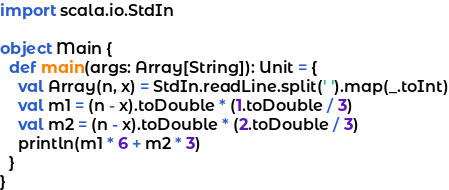<code> <loc_0><loc_0><loc_500><loc_500><_Scala_>import scala.io.StdIn

object Main {
  def main(args: Array[String]): Unit = {
    val Array(n, x) = StdIn.readLine.split(' ').map(_.toInt)
    val m1 = (n - x).toDouble * (1.toDouble / 3)
    val m2 = (n - x).toDouble * (2.toDouble / 3)
    println(m1 * 6 + m2 * 3)
  }
}</code> 